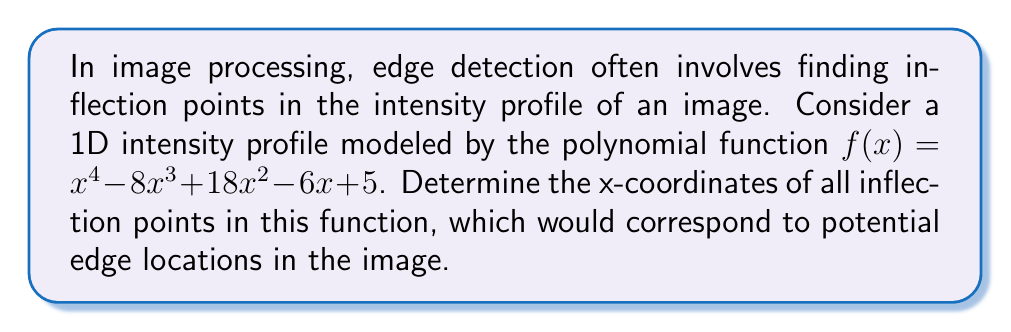Could you help me with this problem? To find the inflection points of the polynomial function, we need to follow these steps:

1) The inflection points occur where the second derivative of the function changes sign. Therefore, we need to find the second derivative and set it equal to zero.

2) First, let's find the first derivative:
   $f'(x) = 4x^3 - 24x^2 + 36x - 6$

3) Now, let's find the second derivative:
   $f''(x) = 12x^2 - 48x + 36$

4) Set the second derivative equal to zero and solve for x:
   $12x^2 - 48x + 36 = 0$

5) This is a quadratic equation. We can solve it using the quadratic formula:
   $x = \frac{-b \pm \sqrt{b^2 - 4ac}}{2a}$

   Where $a = 12$, $b = -48$, and $c = 36$

6) Plugging these values into the quadratic formula:
   $x = \frac{48 \pm \sqrt{(-48)^2 - 4(12)(36)}}{2(12)}$
   
   $= \frac{48 \pm \sqrt{2304 - 1728}}{24}$
   
   $= \frac{48 \pm \sqrt{576}}{24}$
   
   $= \frac{48 \pm 24}{24}$

7) This gives us two solutions:
   $x_1 = \frac{48 + 24}{24} = 3$
   $x_2 = \frac{48 - 24}{24} = 1$

These x-coordinates represent the inflection points of the polynomial function, which correspond to potential edge locations in the image intensity profile.
Answer: The inflection points occur at $x = 1$ and $x = 3$. 